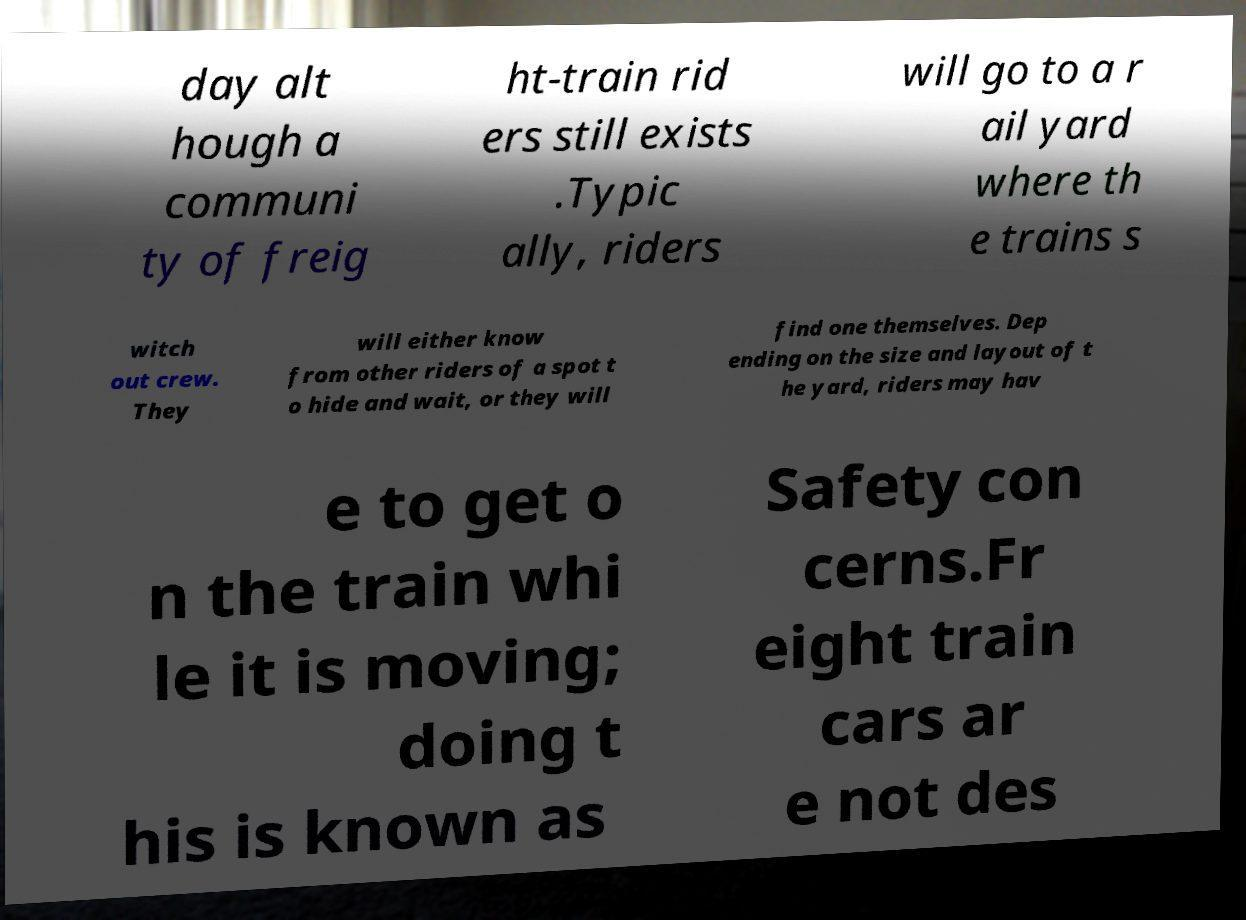Could you assist in decoding the text presented in this image and type it out clearly? day alt hough a communi ty of freig ht-train rid ers still exists .Typic ally, riders will go to a r ail yard where th e trains s witch out crew. They will either know from other riders of a spot t o hide and wait, or they will find one themselves. Dep ending on the size and layout of t he yard, riders may hav e to get o n the train whi le it is moving; doing t his is known as Safety con cerns.Fr eight train cars ar e not des 